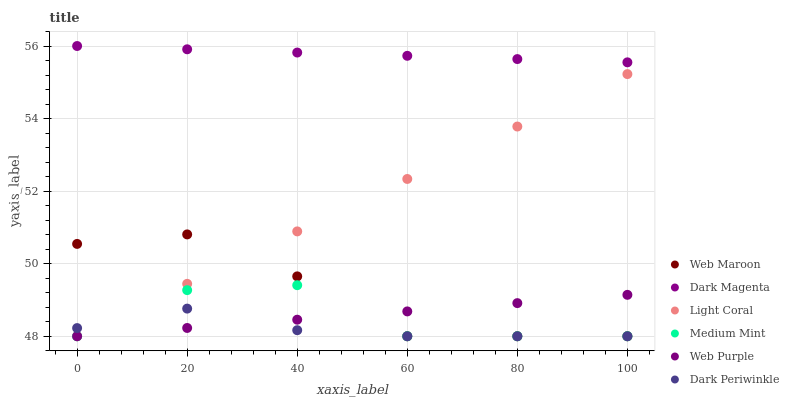Does Dark Periwinkle have the minimum area under the curve?
Answer yes or no. Yes. Does Dark Magenta have the maximum area under the curve?
Answer yes or no. Yes. Does Web Maroon have the minimum area under the curve?
Answer yes or no. No. Does Web Maroon have the maximum area under the curve?
Answer yes or no. No. Is Dark Magenta the smoothest?
Answer yes or no. Yes. Is Medium Mint the roughest?
Answer yes or no. Yes. Is Web Maroon the smoothest?
Answer yes or no. No. Is Web Maroon the roughest?
Answer yes or no. No. Does Medium Mint have the lowest value?
Answer yes or no. Yes. Does Dark Magenta have the lowest value?
Answer yes or no. No. Does Dark Magenta have the highest value?
Answer yes or no. Yes. Does Web Maroon have the highest value?
Answer yes or no. No. Is Light Coral less than Dark Magenta?
Answer yes or no. Yes. Is Dark Magenta greater than Web Purple?
Answer yes or no. Yes. Does Dark Periwinkle intersect Web Maroon?
Answer yes or no. Yes. Is Dark Periwinkle less than Web Maroon?
Answer yes or no. No. Is Dark Periwinkle greater than Web Maroon?
Answer yes or no. No. Does Light Coral intersect Dark Magenta?
Answer yes or no. No. 